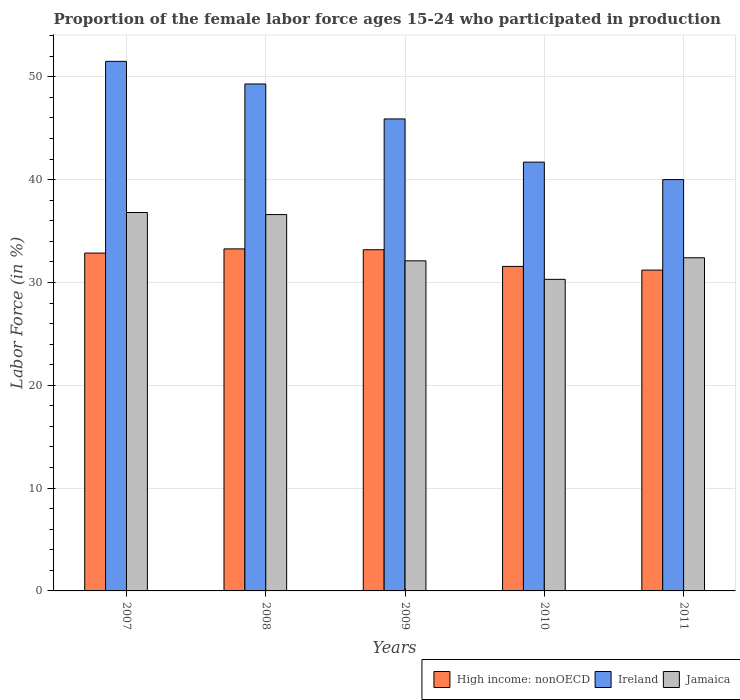Are the number of bars per tick equal to the number of legend labels?
Ensure brevity in your answer.  Yes. Are the number of bars on each tick of the X-axis equal?
Keep it short and to the point. Yes. What is the label of the 1st group of bars from the left?
Your answer should be compact. 2007. In how many cases, is the number of bars for a given year not equal to the number of legend labels?
Ensure brevity in your answer.  0. What is the proportion of the female labor force who participated in production in High income: nonOECD in 2010?
Provide a succinct answer. 31.56. Across all years, what is the maximum proportion of the female labor force who participated in production in Ireland?
Provide a succinct answer. 51.5. Across all years, what is the minimum proportion of the female labor force who participated in production in Ireland?
Keep it short and to the point. 40. In which year was the proportion of the female labor force who participated in production in Ireland minimum?
Offer a very short reply. 2011. What is the total proportion of the female labor force who participated in production in Ireland in the graph?
Provide a short and direct response. 228.4. What is the difference between the proportion of the female labor force who participated in production in Jamaica in 2007 and the proportion of the female labor force who participated in production in Ireland in 2009?
Give a very brief answer. -9.1. What is the average proportion of the female labor force who participated in production in High income: nonOECD per year?
Offer a very short reply. 32.41. In the year 2011, what is the difference between the proportion of the female labor force who participated in production in Ireland and proportion of the female labor force who participated in production in Jamaica?
Offer a very short reply. 7.6. What is the ratio of the proportion of the female labor force who participated in production in High income: nonOECD in 2009 to that in 2010?
Make the answer very short. 1.05. Is the proportion of the female labor force who participated in production in Ireland in 2007 less than that in 2010?
Your response must be concise. No. Is the difference between the proportion of the female labor force who participated in production in Ireland in 2010 and 2011 greater than the difference between the proportion of the female labor force who participated in production in Jamaica in 2010 and 2011?
Ensure brevity in your answer.  Yes. What is the difference between the highest and the second highest proportion of the female labor force who participated in production in High income: nonOECD?
Your response must be concise. 0.08. What is the difference between the highest and the lowest proportion of the female labor force who participated in production in Jamaica?
Offer a terse response. 6.5. What does the 3rd bar from the left in 2011 represents?
Provide a short and direct response. Jamaica. What does the 2nd bar from the right in 2007 represents?
Your response must be concise. Ireland. How many bars are there?
Keep it short and to the point. 15. Are all the bars in the graph horizontal?
Offer a very short reply. No. How many years are there in the graph?
Your answer should be very brief. 5. What is the difference between two consecutive major ticks on the Y-axis?
Your answer should be compact. 10. How are the legend labels stacked?
Keep it short and to the point. Horizontal. What is the title of the graph?
Provide a succinct answer. Proportion of the female labor force ages 15-24 who participated in production. Does "East Asia (all income levels)" appear as one of the legend labels in the graph?
Provide a short and direct response. No. What is the Labor Force (in %) in High income: nonOECD in 2007?
Your answer should be very brief. 32.85. What is the Labor Force (in %) of Ireland in 2007?
Offer a terse response. 51.5. What is the Labor Force (in %) in Jamaica in 2007?
Ensure brevity in your answer.  36.8. What is the Labor Force (in %) of High income: nonOECD in 2008?
Your answer should be very brief. 33.26. What is the Labor Force (in %) in Ireland in 2008?
Provide a short and direct response. 49.3. What is the Labor Force (in %) in Jamaica in 2008?
Keep it short and to the point. 36.6. What is the Labor Force (in %) in High income: nonOECD in 2009?
Your response must be concise. 33.18. What is the Labor Force (in %) in Ireland in 2009?
Your answer should be very brief. 45.9. What is the Labor Force (in %) in Jamaica in 2009?
Make the answer very short. 32.1. What is the Labor Force (in %) of High income: nonOECD in 2010?
Your answer should be very brief. 31.56. What is the Labor Force (in %) in Ireland in 2010?
Offer a terse response. 41.7. What is the Labor Force (in %) in Jamaica in 2010?
Give a very brief answer. 30.3. What is the Labor Force (in %) of High income: nonOECD in 2011?
Offer a very short reply. 31.2. What is the Labor Force (in %) of Jamaica in 2011?
Give a very brief answer. 32.4. Across all years, what is the maximum Labor Force (in %) in High income: nonOECD?
Your response must be concise. 33.26. Across all years, what is the maximum Labor Force (in %) in Ireland?
Keep it short and to the point. 51.5. Across all years, what is the maximum Labor Force (in %) in Jamaica?
Provide a succinct answer. 36.8. Across all years, what is the minimum Labor Force (in %) of High income: nonOECD?
Provide a succinct answer. 31.2. Across all years, what is the minimum Labor Force (in %) of Ireland?
Provide a succinct answer. 40. Across all years, what is the minimum Labor Force (in %) of Jamaica?
Your answer should be compact. 30.3. What is the total Labor Force (in %) of High income: nonOECD in the graph?
Offer a very short reply. 162.06. What is the total Labor Force (in %) of Ireland in the graph?
Keep it short and to the point. 228.4. What is the total Labor Force (in %) of Jamaica in the graph?
Your answer should be very brief. 168.2. What is the difference between the Labor Force (in %) of High income: nonOECD in 2007 and that in 2008?
Provide a succinct answer. -0.41. What is the difference between the Labor Force (in %) of Ireland in 2007 and that in 2008?
Your answer should be compact. 2.2. What is the difference between the Labor Force (in %) in High income: nonOECD in 2007 and that in 2009?
Provide a short and direct response. -0.33. What is the difference between the Labor Force (in %) in Ireland in 2007 and that in 2009?
Give a very brief answer. 5.6. What is the difference between the Labor Force (in %) of High income: nonOECD in 2007 and that in 2010?
Your response must be concise. 1.3. What is the difference between the Labor Force (in %) in Ireland in 2007 and that in 2010?
Ensure brevity in your answer.  9.8. What is the difference between the Labor Force (in %) of Jamaica in 2007 and that in 2010?
Ensure brevity in your answer.  6.5. What is the difference between the Labor Force (in %) in High income: nonOECD in 2007 and that in 2011?
Keep it short and to the point. 1.65. What is the difference between the Labor Force (in %) in Jamaica in 2007 and that in 2011?
Offer a terse response. 4.4. What is the difference between the Labor Force (in %) of High income: nonOECD in 2008 and that in 2009?
Ensure brevity in your answer.  0.08. What is the difference between the Labor Force (in %) of High income: nonOECD in 2008 and that in 2010?
Make the answer very short. 1.71. What is the difference between the Labor Force (in %) of High income: nonOECD in 2008 and that in 2011?
Your response must be concise. 2.06. What is the difference between the Labor Force (in %) in Jamaica in 2008 and that in 2011?
Keep it short and to the point. 4.2. What is the difference between the Labor Force (in %) in High income: nonOECD in 2009 and that in 2010?
Offer a very short reply. 1.62. What is the difference between the Labor Force (in %) of High income: nonOECD in 2009 and that in 2011?
Your answer should be compact. 1.98. What is the difference between the Labor Force (in %) in High income: nonOECD in 2010 and that in 2011?
Your answer should be very brief. 0.36. What is the difference between the Labor Force (in %) of High income: nonOECD in 2007 and the Labor Force (in %) of Ireland in 2008?
Ensure brevity in your answer.  -16.45. What is the difference between the Labor Force (in %) of High income: nonOECD in 2007 and the Labor Force (in %) of Jamaica in 2008?
Your answer should be very brief. -3.75. What is the difference between the Labor Force (in %) in High income: nonOECD in 2007 and the Labor Force (in %) in Ireland in 2009?
Your response must be concise. -13.05. What is the difference between the Labor Force (in %) in High income: nonOECD in 2007 and the Labor Force (in %) in Jamaica in 2009?
Make the answer very short. 0.75. What is the difference between the Labor Force (in %) in High income: nonOECD in 2007 and the Labor Force (in %) in Ireland in 2010?
Give a very brief answer. -8.85. What is the difference between the Labor Force (in %) in High income: nonOECD in 2007 and the Labor Force (in %) in Jamaica in 2010?
Give a very brief answer. 2.55. What is the difference between the Labor Force (in %) of Ireland in 2007 and the Labor Force (in %) of Jamaica in 2010?
Provide a succinct answer. 21.2. What is the difference between the Labor Force (in %) of High income: nonOECD in 2007 and the Labor Force (in %) of Ireland in 2011?
Make the answer very short. -7.15. What is the difference between the Labor Force (in %) of High income: nonOECD in 2007 and the Labor Force (in %) of Jamaica in 2011?
Offer a very short reply. 0.45. What is the difference between the Labor Force (in %) in Ireland in 2007 and the Labor Force (in %) in Jamaica in 2011?
Offer a very short reply. 19.1. What is the difference between the Labor Force (in %) of High income: nonOECD in 2008 and the Labor Force (in %) of Ireland in 2009?
Ensure brevity in your answer.  -12.64. What is the difference between the Labor Force (in %) in High income: nonOECD in 2008 and the Labor Force (in %) in Jamaica in 2009?
Offer a terse response. 1.16. What is the difference between the Labor Force (in %) of High income: nonOECD in 2008 and the Labor Force (in %) of Ireland in 2010?
Keep it short and to the point. -8.44. What is the difference between the Labor Force (in %) of High income: nonOECD in 2008 and the Labor Force (in %) of Jamaica in 2010?
Provide a succinct answer. 2.96. What is the difference between the Labor Force (in %) in Ireland in 2008 and the Labor Force (in %) in Jamaica in 2010?
Keep it short and to the point. 19. What is the difference between the Labor Force (in %) in High income: nonOECD in 2008 and the Labor Force (in %) in Ireland in 2011?
Give a very brief answer. -6.74. What is the difference between the Labor Force (in %) of High income: nonOECD in 2008 and the Labor Force (in %) of Jamaica in 2011?
Offer a very short reply. 0.86. What is the difference between the Labor Force (in %) in High income: nonOECD in 2009 and the Labor Force (in %) in Ireland in 2010?
Your answer should be compact. -8.52. What is the difference between the Labor Force (in %) of High income: nonOECD in 2009 and the Labor Force (in %) of Jamaica in 2010?
Provide a succinct answer. 2.88. What is the difference between the Labor Force (in %) of High income: nonOECD in 2009 and the Labor Force (in %) of Ireland in 2011?
Keep it short and to the point. -6.82. What is the difference between the Labor Force (in %) of High income: nonOECD in 2009 and the Labor Force (in %) of Jamaica in 2011?
Give a very brief answer. 0.78. What is the difference between the Labor Force (in %) of High income: nonOECD in 2010 and the Labor Force (in %) of Ireland in 2011?
Offer a very short reply. -8.44. What is the difference between the Labor Force (in %) in High income: nonOECD in 2010 and the Labor Force (in %) in Jamaica in 2011?
Your answer should be compact. -0.84. What is the average Labor Force (in %) of High income: nonOECD per year?
Offer a terse response. 32.41. What is the average Labor Force (in %) of Ireland per year?
Provide a succinct answer. 45.68. What is the average Labor Force (in %) in Jamaica per year?
Your answer should be very brief. 33.64. In the year 2007, what is the difference between the Labor Force (in %) of High income: nonOECD and Labor Force (in %) of Ireland?
Your answer should be very brief. -18.65. In the year 2007, what is the difference between the Labor Force (in %) in High income: nonOECD and Labor Force (in %) in Jamaica?
Give a very brief answer. -3.95. In the year 2008, what is the difference between the Labor Force (in %) in High income: nonOECD and Labor Force (in %) in Ireland?
Your answer should be compact. -16.04. In the year 2008, what is the difference between the Labor Force (in %) in High income: nonOECD and Labor Force (in %) in Jamaica?
Provide a succinct answer. -3.34. In the year 2009, what is the difference between the Labor Force (in %) in High income: nonOECD and Labor Force (in %) in Ireland?
Your answer should be very brief. -12.72. In the year 2009, what is the difference between the Labor Force (in %) in High income: nonOECD and Labor Force (in %) in Jamaica?
Your response must be concise. 1.08. In the year 2010, what is the difference between the Labor Force (in %) of High income: nonOECD and Labor Force (in %) of Ireland?
Ensure brevity in your answer.  -10.14. In the year 2010, what is the difference between the Labor Force (in %) of High income: nonOECD and Labor Force (in %) of Jamaica?
Your response must be concise. 1.26. In the year 2011, what is the difference between the Labor Force (in %) in High income: nonOECD and Labor Force (in %) in Ireland?
Provide a succinct answer. -8.8. In the year 2011, what is the difference between the Labor Force (in %) of High income: nonOECD and Labor Force (in %) of Jamaica?
Make the answer very short. -1.2. What is the ratio of the Labor Force (in %) in Ireland in 2007 to that in 2008?
Provide a short and direct response. 1.04. What is the ratio of the Labor Force (in %) of High income: nonOECD in 2007 to that in 2009?
Keep it short and to the point. 0.99. What is the ratio of the Labor Force (in %) in Ireland in 2007 to that in 2009?
Ensure brevity in your answer.  1.12. What is the ratio of the Labor Force (in %) of Jamaica in 2007 to that in 2009?
Your response must be concise. 1.15. What is the ratio of the Labor Force (in %) in High income: nonOECD in 2007 to that in 2010?
Provide a short and direct response. 1.04. What is the ratio of the Labor Force (in %) of Ireland in 2007 to that in 2010?
Offer a terse response. 1.24. What is the ratio of the Labor Force (in %) in Jamaica in 2007 to that in 2010?
Provide a short and direct response. 1.21. What is the ratio of the Labor Force (in %) in High income: nonOECD in 2007 to that in 2011?
Give a very brief answer. 1.05. What is the ratio of the Labor Force (in %) in Ireland in 2007 to that in 2011?
Your answer should be compact. 1.29. What is the ratio of the Labor Force (in %) of Jamaica in 2007 to that in 2011?
Your response must be concise. 1.14. What is the ratio of the Labor Force (in %) of High income: nonOECD in 2008 to that in 2009?
Keep it short and to the point. 1. What is the ratio of the Labor Force (in %) of Ireland in 2008 to that in 2009?
Offer a terse response. 1.07. What is the ratio of the Labor Force (in %) in Jamaica in 2008 to that in 2009?
Make the answer very short. 1.14. What is the ratio of the Labor Force (in %) of High income: nonOECD in 2008 to that in 2010?
Your answer should be very brief. 1.05. What is the ratio of the Labor Force (in %) of Ireland in 2008 to that in 2010?
Offer a terse response. 1.18. What is the ratio of the Labor Force (in %) of Jamaica in 2008 to that in 2010?
Your answer should be compact. 1.21. What is the ratio of the Labor Force (in %) of High income: nonOECD in 2008 to that in 2011?
Provide a short and direct response. 1.07. What is the ratio of the Labor Force (in %) in Ireland in 2008 to that in 2011?
Ensure brevity in your answer.  1.23. What is the ratio of the Labor Force (in %) of Jamaica in 2008 to that in 2011?
Your answer should be compact. 1.13. What is the ratio of the Labor Force (in %) of High income: nonOECD in 2009 to that in 2010?
Offer a very short reply. 1.05. What is the ratio of the Labor Force (in %) in Ireland in 2009 to that in 2010?
Your answer should be very brief. 1.1. What is the ratio of the Labor Force (in %) in Jamaica in 2009 to that in 2010?
Your answer should be very brief. 1.06. What is the ratio of the Labor Force (in %) in High income: nonOECD in 2009 to that in 2011?
Ensure brevity in your answer.  1.06. What is the ratio of the Labor Force (in %) in Ireland in 2009 to that in 2011?
Your response must be concise. 1.15. What is the ratio of the Labor Force (in %) of High income: nonOECD in 2010 to that in 2011?
Offer a terse response. 1.01. What is the ratio of the Labor Force (in %) in Ireland in 2010 to that in 2011?
Give a very brief answer. 1.04. What is the ratio of the Labor Force (in %) in Jamaica in 2010 to that in 2011?
Your answer should be compact. 0.94. What is the difference between the highest and the second highest Labor Force (in %) of High income: nonOECD?
Your answer should be very brief. 0.08. What is the difference between the highest and the second highest Labor Force (in %) of Jamaica?
Keep it short and to the point. 0.2. What is the difference between the highest and the lowest Labor Force (in %) of High income: nonOECD?
Ensure brevity in your answer.  2.06. What is the difference between the highest and the lowest Labor Force (in %) in Jamaica?
Make the answer very short. 6.5. 